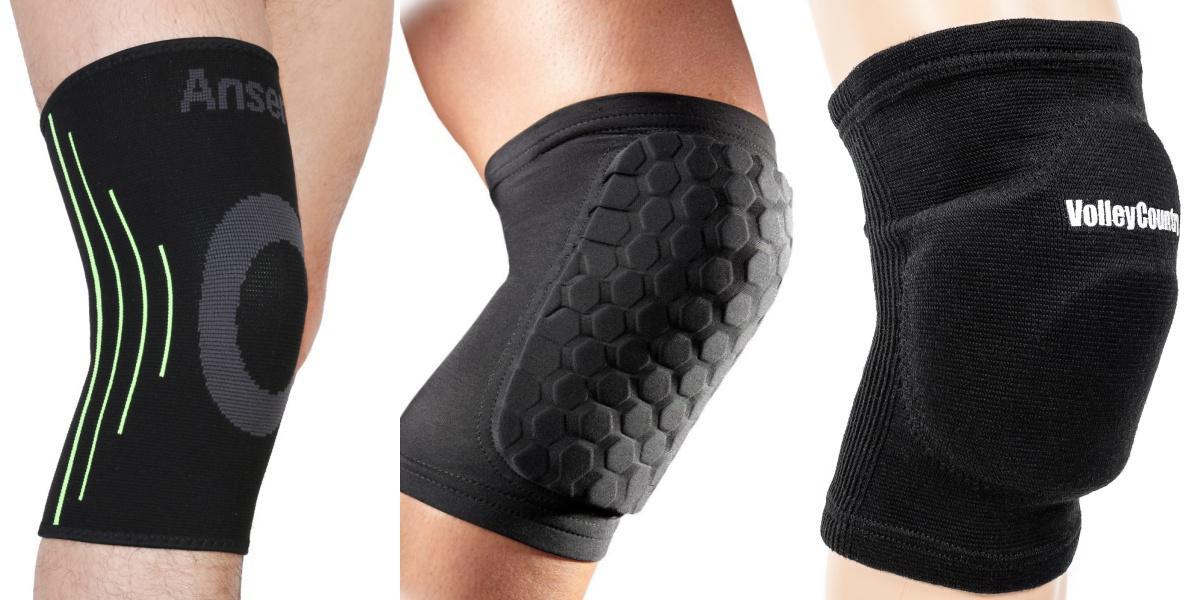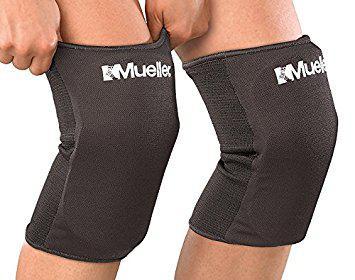The first image is the image on the left, the second image is the image on the right. For the images shown, is this caption "At least one pair of kneepads is worn by a human." true? Answer yes or no. Yes. The first image is the image on the left, the second image is the image on the right. Examine the images to the left and right. Is the description "Three of the four total knee pads are black" accurate? Answer yes or no. No. The first image is the image on the left, the second image is the image on the right. For the images shown, is this caption "There are three black knee braces and one white knee brace." true? Answer yes or no. No. The first image is the image on the left, the second image is the image on the right. Evaluate the accuracy of this statement regarding the images: "One image shows one each of white and black knee pads.". Is it true? Answer yes or no. No. 